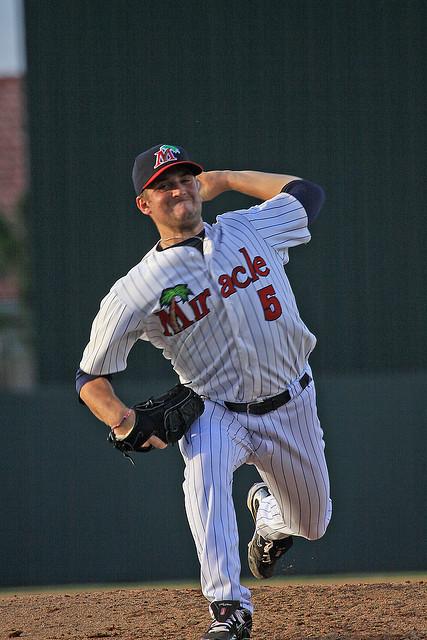What is the man's dominant hand?
Short answer required. Left. What does his shirt say?
Answer briefly. Miracle. What team is pitching?
Write a very short answer. Miracle. What number is on his jersey?
Keep it brief. 5. 